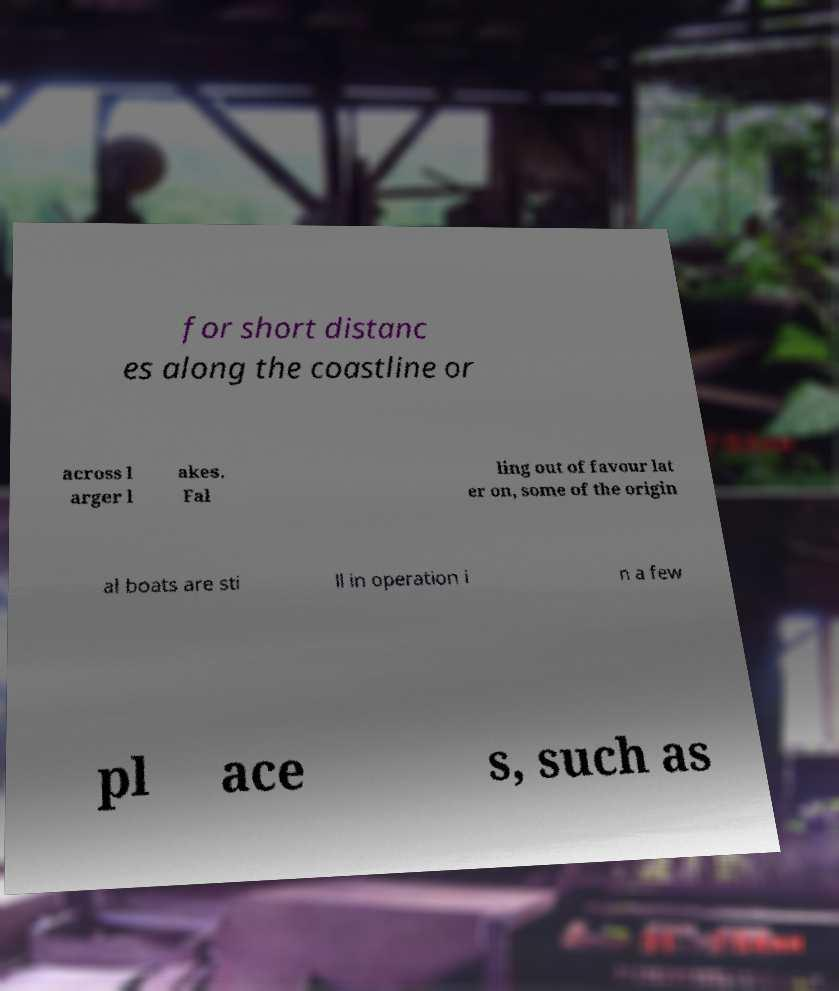Can you read and provide the text displayed in the image?This photo seems to have some interesting text. Can you extract and type it out for me? for short distanc es along the coastline or across l arger l akes. Fal ling out of favour lat er on, some of the origin al boats are sti ll in operation i n a few pl ace s, such as 